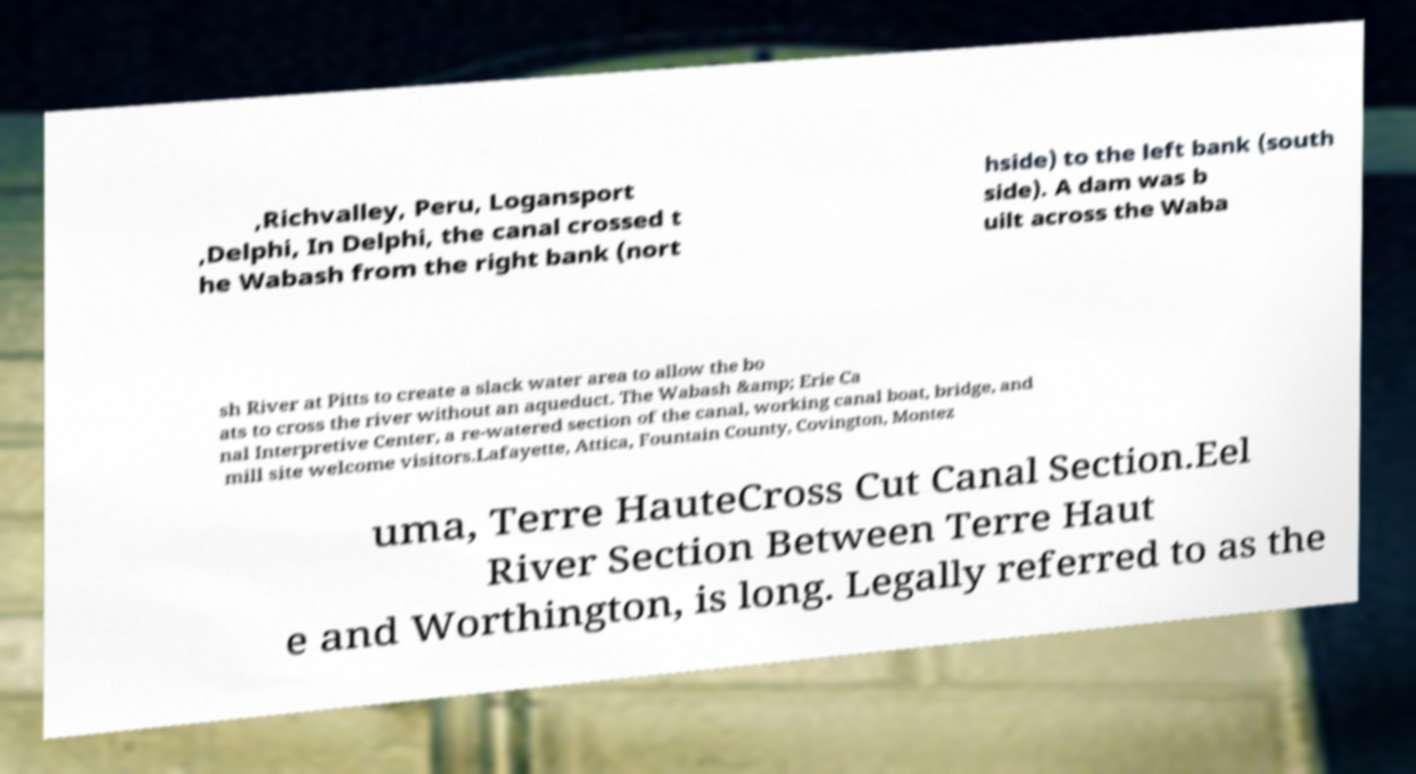Please identify and transcribe the text found in this image. ,Richvalley, Peru, Logansport ,Delphi, In Delphi, the canal crossed t he Wabash from the right bank (nort hside) to the left bank (south side). A dam was b uilt across the Waba sh River at Pitts to create a slack water area to allow the bo ats to cross the river without an aqueduct. The Wabash &amp; Erie Ca nal Interpretive Center, a re-watered section of the canal, working canal boat, bridge, and mill site welcome visitors.Lafayette, Attica, Fountain County, Covington, Montez uma, Terre HauteCross Cut Canal Section.Eel River Section Between Terre Haut e and Worthington, is long. Legally referred to as the 